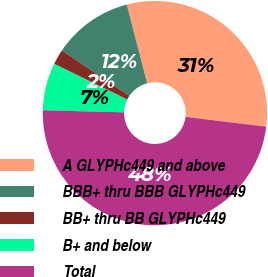Convert chart. <chart><loc_0><loc_0><loc_500><loc_500><pie_chart><fcel>A GLYPHc449 and above<fcel>BBB+ thru BBB GLYPHc449<fcel>BB+ thru BB GLYPHc449<fcel>B+ and below<fcel>Total<nl><fcel>30.98%<fcel>11.52%<fcel>2.2%<fcel>6.83%<fcel>48.48%<nl></chart> 